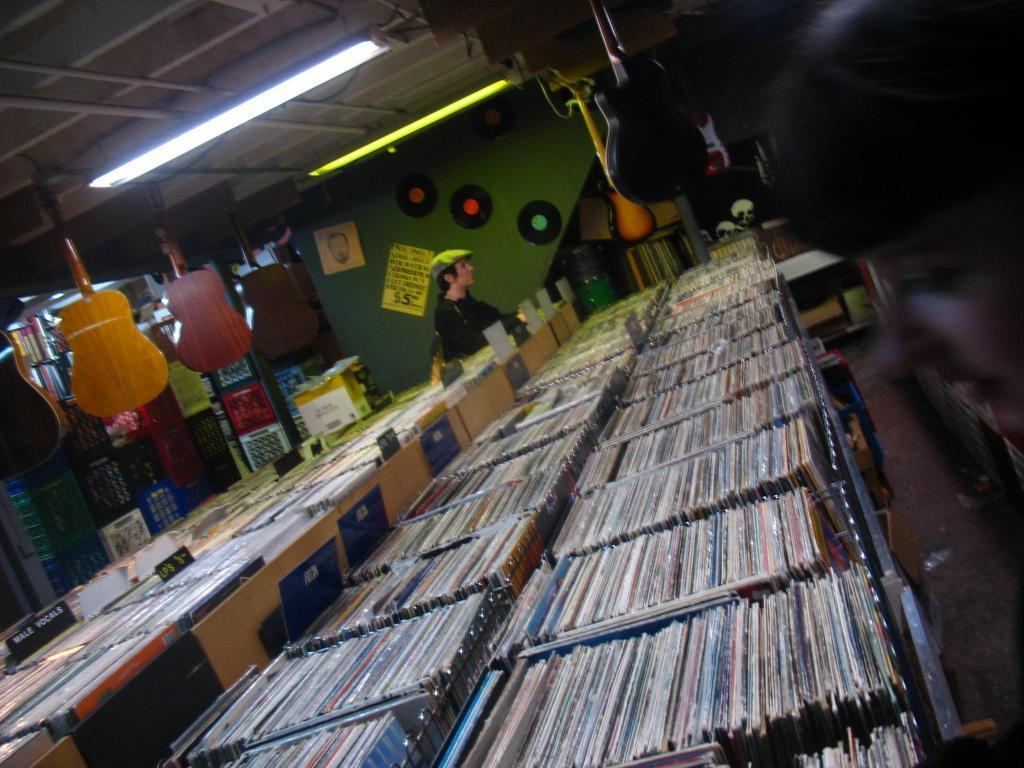In one or two sentences, can you explain what this image depicts? there are many books in the rows. behind them a person is standing. at the back there is green wall. and on the top guitars are hanging. 